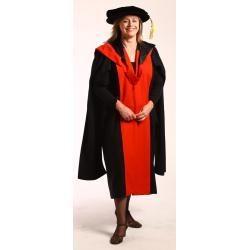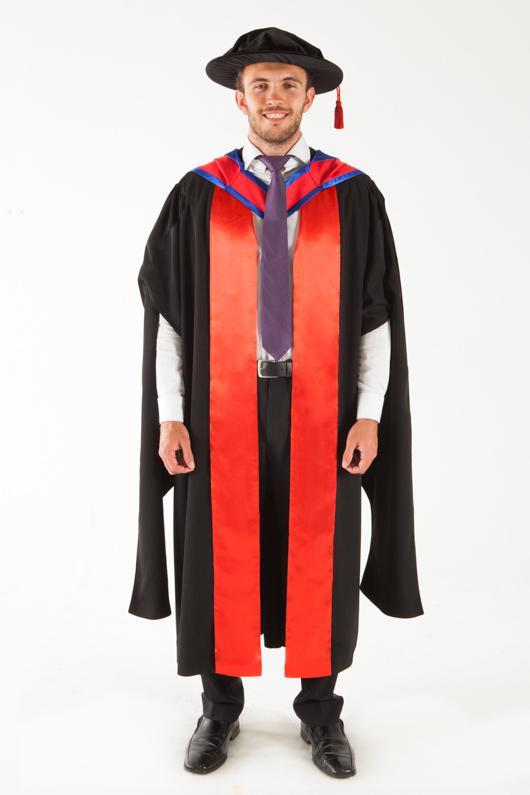The first image is the image on the left, the second image is the image on the right. Analyze the images presented: Is the assertion "Each graduate model wears a black robe and a square-topped black hat with black tassel, but one model is a dark-haired girl and the other is a young man wearing a purple necktie." valid? Answer yes or no. No. The first image is the image on the left, the second image is the image on the right. Given the left and right images, does the statement "The graduate attire in both images incorporate shades of red." hold true? Answer yes or no. Yes. 